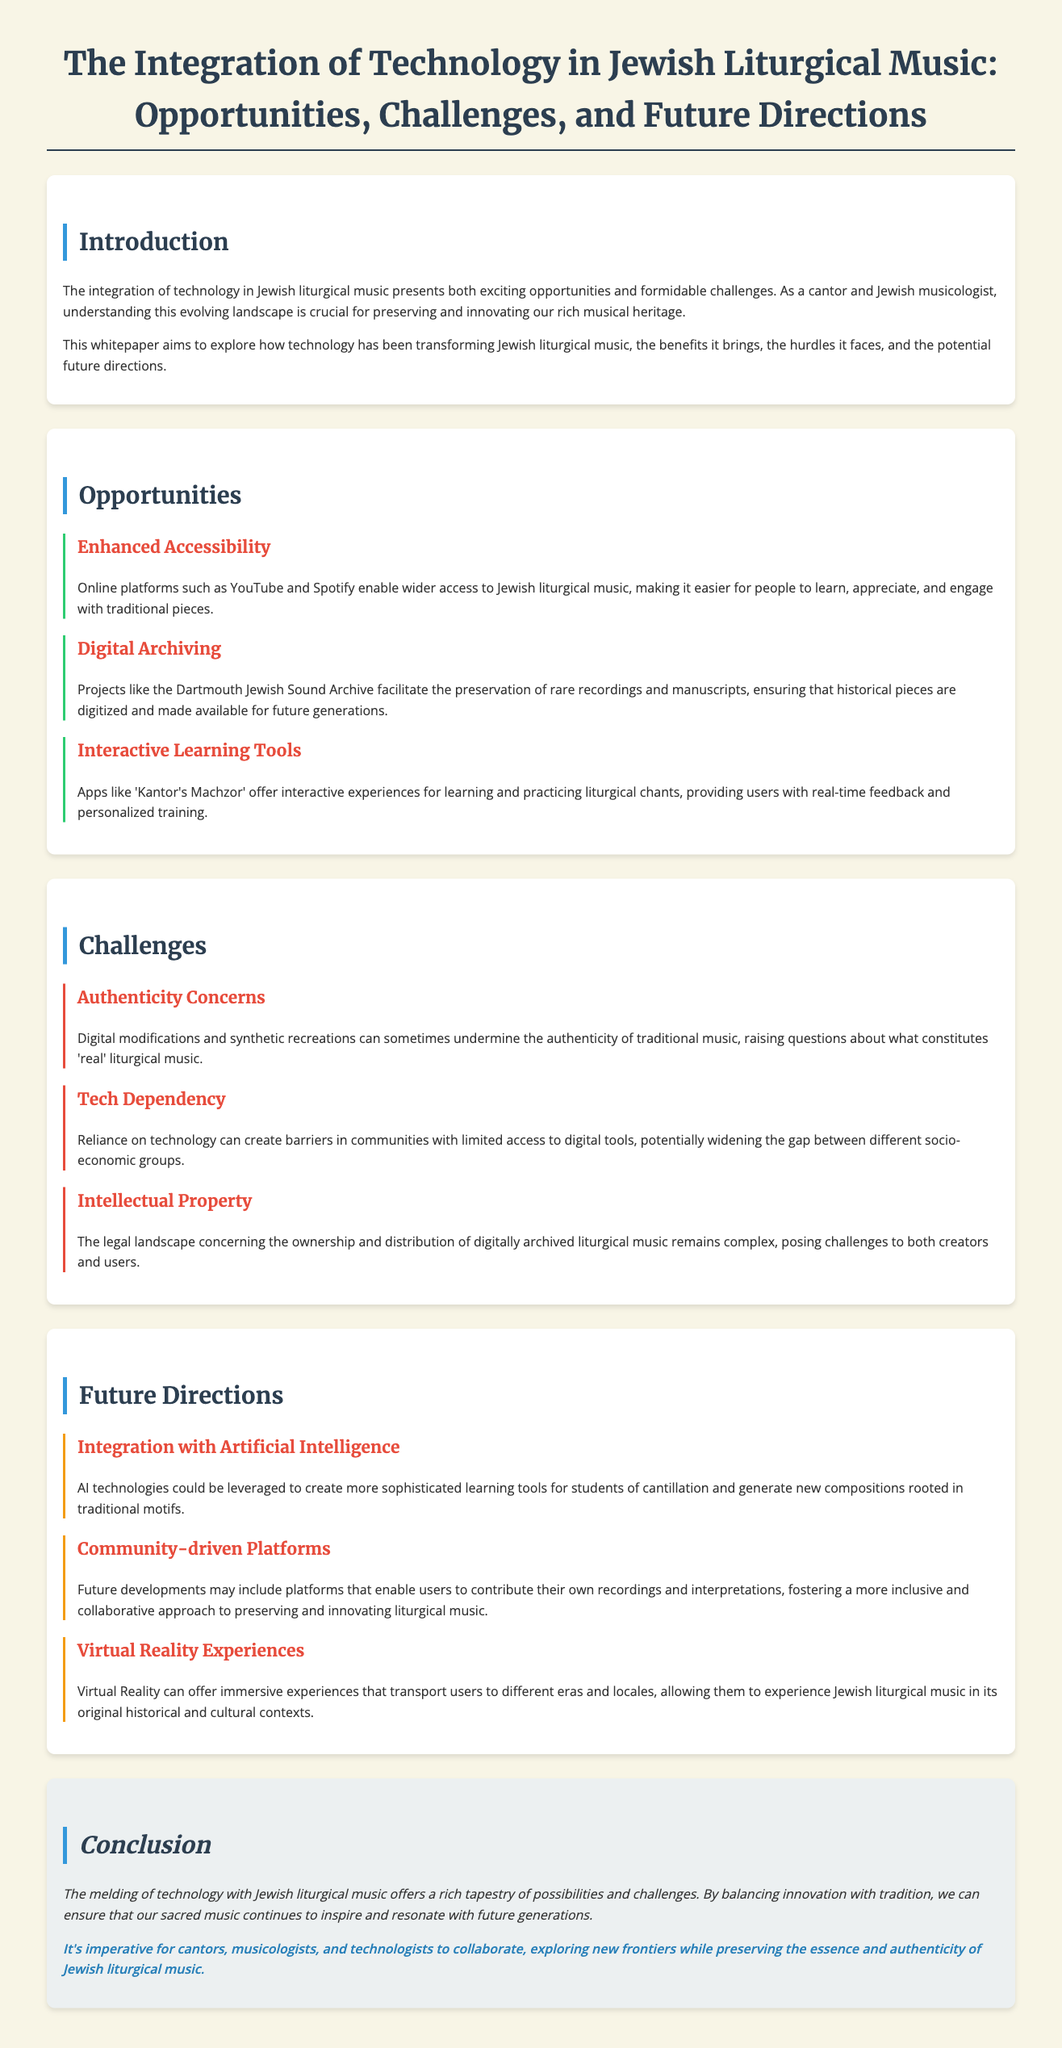What is the title of the whitepaper? The title of the whitepaper is presented at the top of the document.
Answer: The Integration of Technology in Jewish Liturgical Music: Opportunities, Challenges, and Future Directions What online platforms enhance accessibility to Jewish liturgical music? The document mentions online platforms that facilitate access to music.
Answer: YouTube and Spotify What project helps preserve rare recordings and manuscripts? The document states specific projects that support preservation efforts.
Answer: Dartmouth Jewish Sound Archive What is one concern regarding digital modifications in liturgical music? The document identifies issues related to authenticity in liturgical music.
Answer: Authenticity Concerns What dependency issue is mentioned in relation to technology? The document highlights a specific challenge with technology use in communities.
Answer: Tech Dependency What future direction involves using AI in Jewish liturgical music? A future direction discussed in the document pertains to advanced technology.
Answer: Integration with Artificial Intelligence How can technology create immersive experiences for users? The document suggests a specific technology for enhancing experience.
Answer: Virtual Reality Experiences What collaborative action is recommended for preserving Jewish liturgical music? The conclusion emphasizes a particular collaboration for future efforts.
Answer: Collaborate What type of tools can be enhanced by AI, according to the document? The document discusses specific tools that could benefit from AI integration.
Answer: Learning tools 